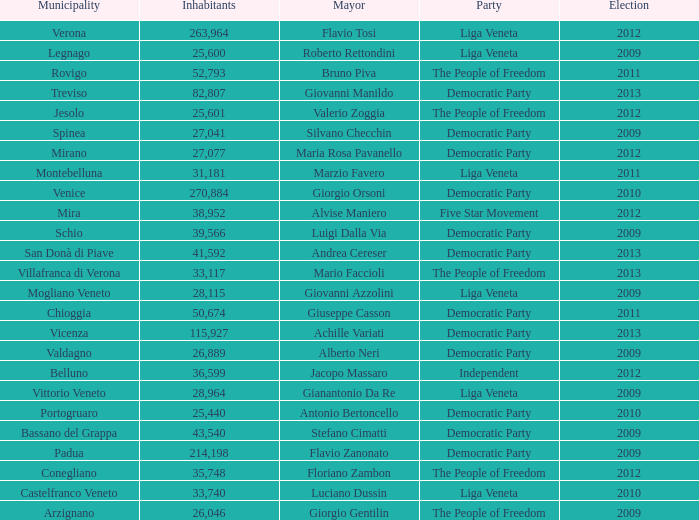In the election earlier than 2012 how many Inhabitants had a Party of five star movement? None. 